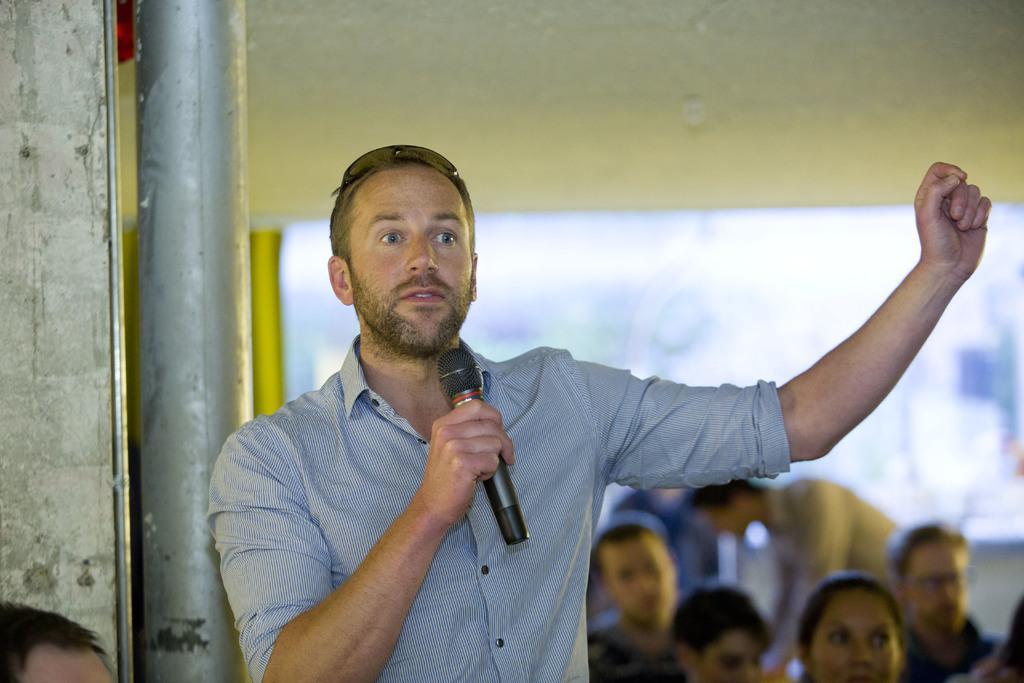How would you summarize this image in a sentence or two? In this picture there is a person wearing blue shirt is standing and speaking in front of a mic and there is a pole behind him and there are few other persons in the background and there is another person in the left bottom corner. 